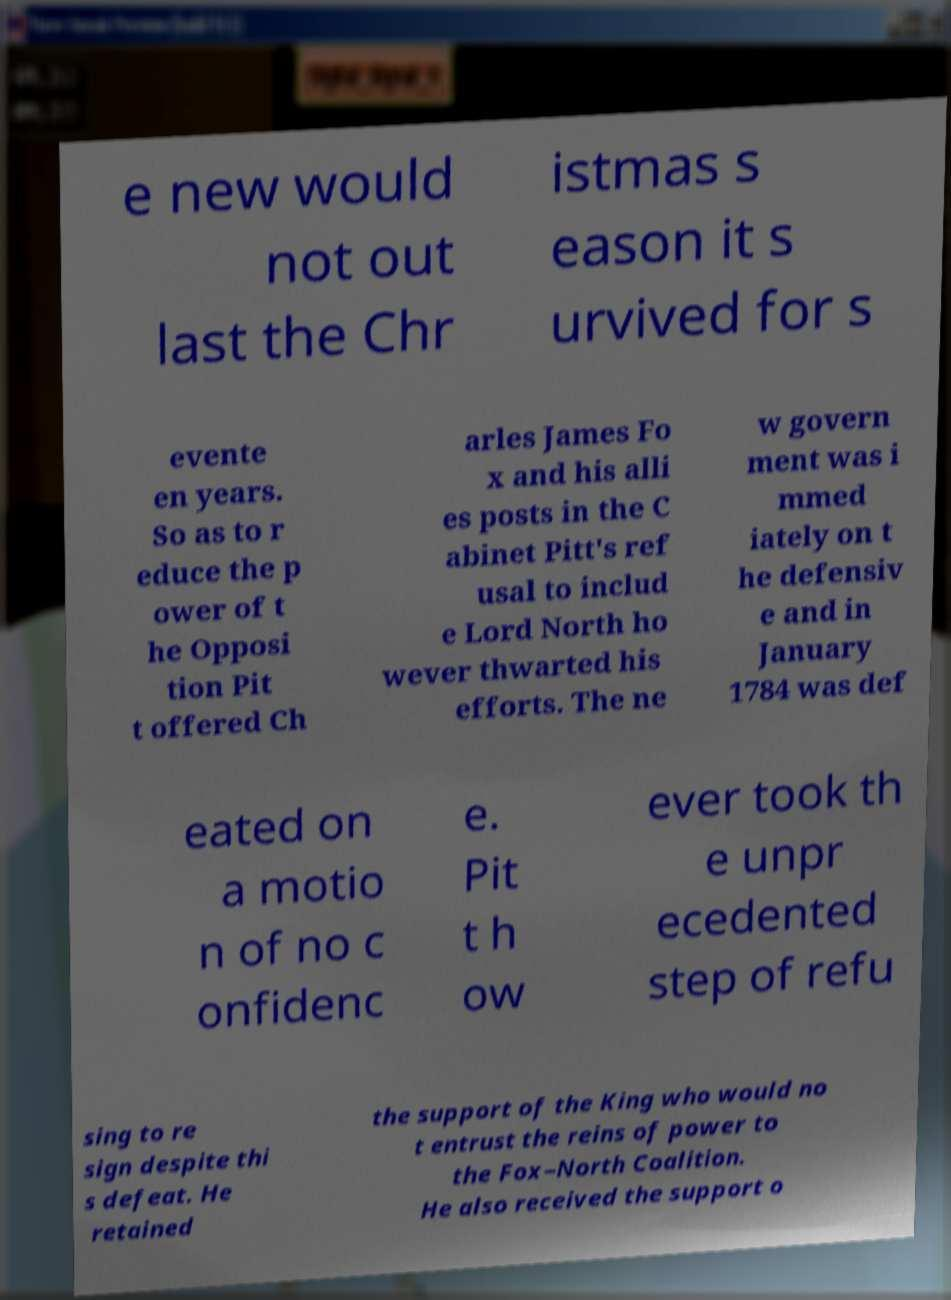Please read and relay the text visible in this image. What does it say? e new would not out last the Chr istmas s eason it s urvived for s evente en years. So as to r educe the p ower of t he Opposi tion Pit t offered Ch arles James Fo x and his alli es posts in the C abinet Pitt's ref usal to includ e Lord North ho wever thwarted his efforts. The ne w govern ment was i mmed iately on t he defensiv e and in January 1784 was def eated on a motio n of no c onfidenc e. Pit t h ow ever took th e unpr ecedented step of refu sing to re sign despite thi s defeat. He retained the support of the King who would no t entrust the reins of power to the Fox–North Coalition. He also received the support o 